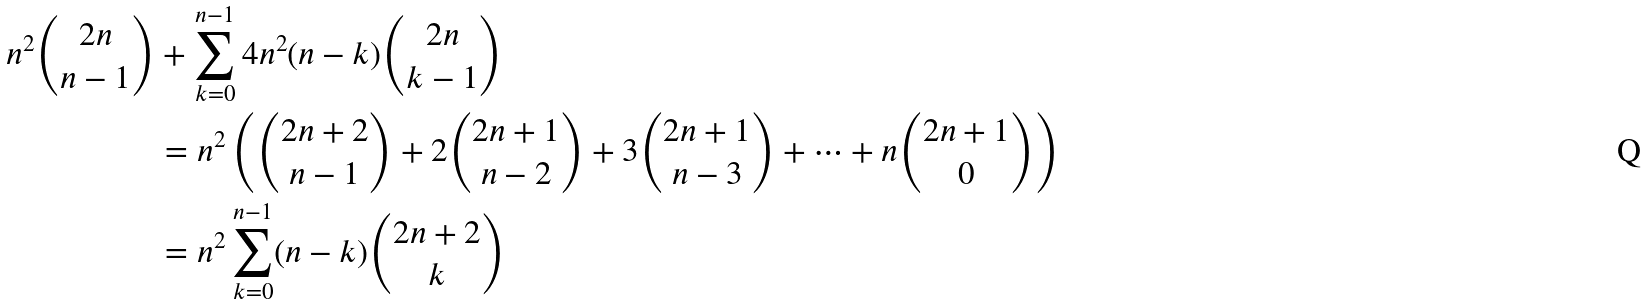Convert formula to latex. <formula><loc_0><loc_0><loc_500><loc_500>n ^ { 2 } { 2 n \choose n - 1 } & + \sum _ { k = 0 } ^ { n - 1 } 4 n ^ { 2 } ( n - k ) { 2 n \choose k - 1 } \\ & = n ^ { 2 } \left ( { 2 n + 2 \choose n - 1 } + 2 { 2 n + 1 \choose n - 2 } + 3 { 2 n + 1 \choose n - 3 } + \dots + n { 2 n + 1 \choose 0 } \right ) \\ & = n ^ { 2 } \sum _ { k = 0 } ^ { n - 1 } ( n - k ) { 2 n + 2 \choose k }</formula> 